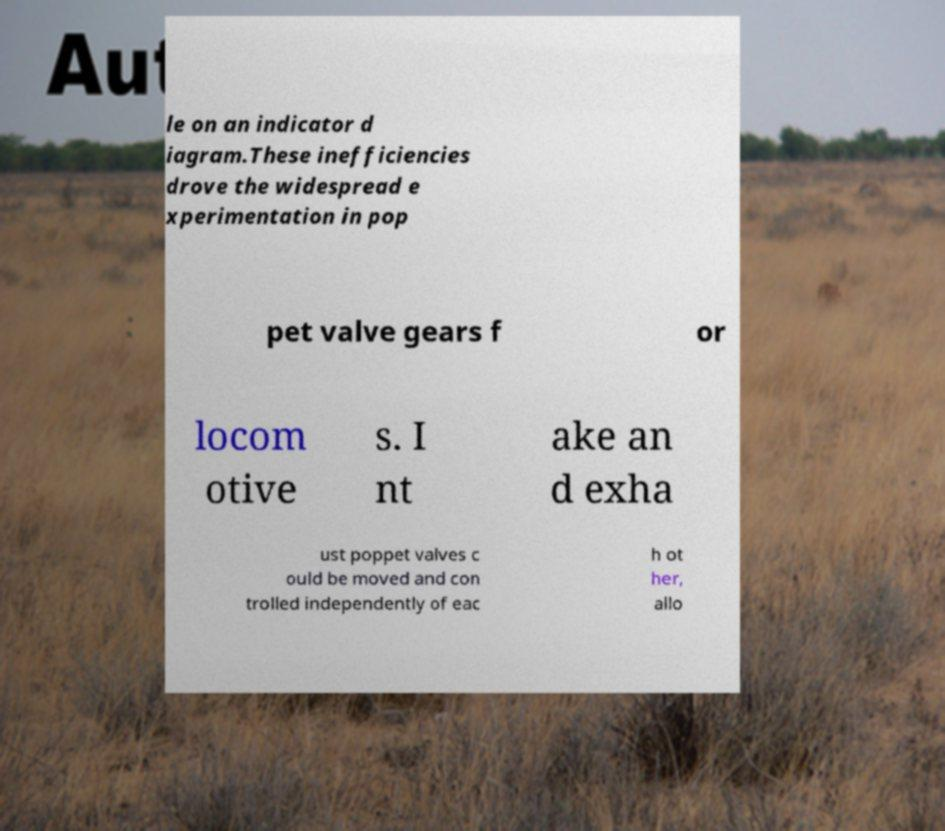For documentation purposes, I need the text within this image transcribed. Could you provide that? le on an indicator d iagram.These inefficiencies drove the widespread e xperimentation in pop pet valve gears f or locom otive s. I nt ake an d exha ust poppet valves c ould be moved and con trolled independently of eac h ot her, allo 